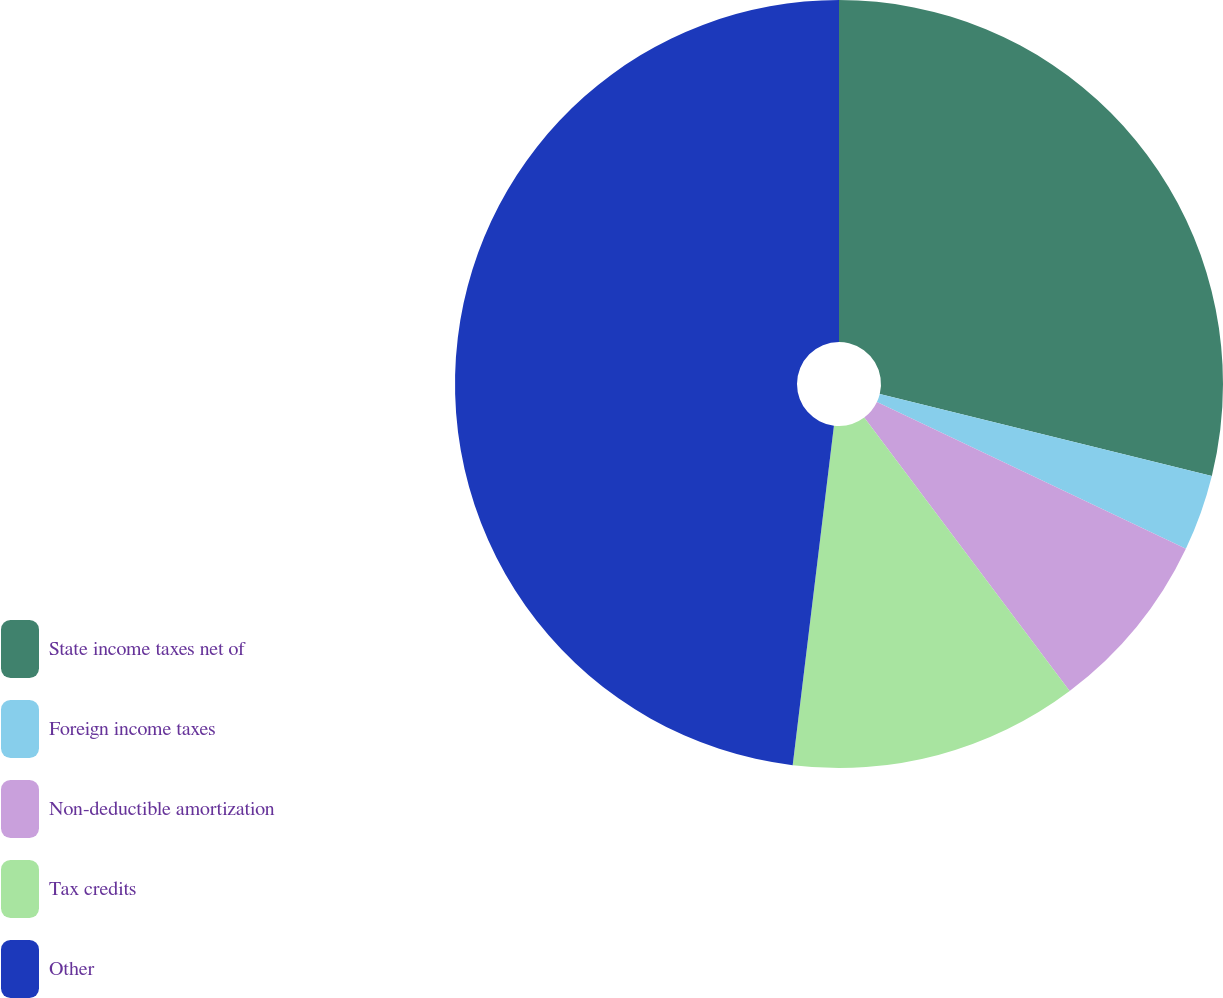<chart> <loc_0><loc_0><loc_500><loc_500><pie_chart><fcel>State income taxes net of<fcel>Foreign income taxes<fcel>Non-deductible amortization<fcel>Tax credits<fcel>Other<nl><fcel>28.85%<fcel>3.21%<fcel>7.69%<fcel>12.18%<fcel>48.08%<nl></chart> 